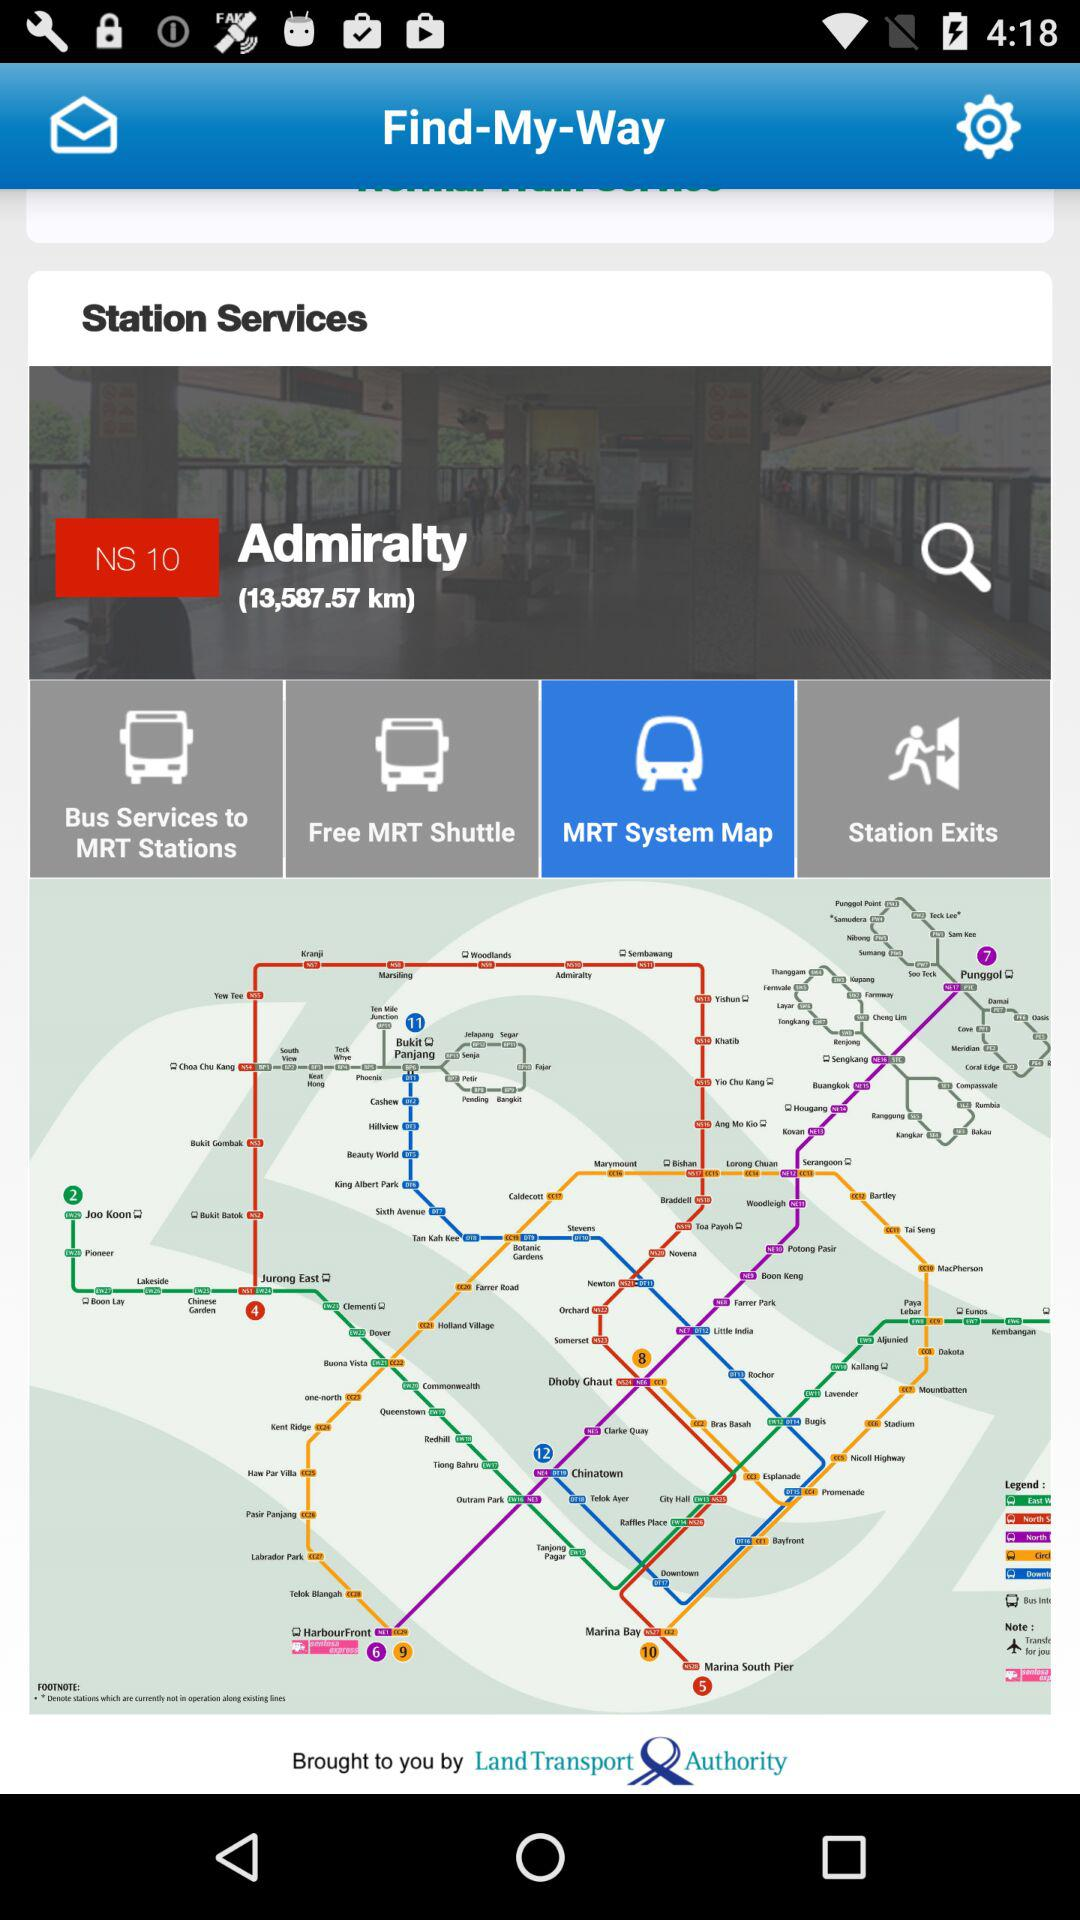What is the distance covered? The distance covered is 13,587.57 km. 